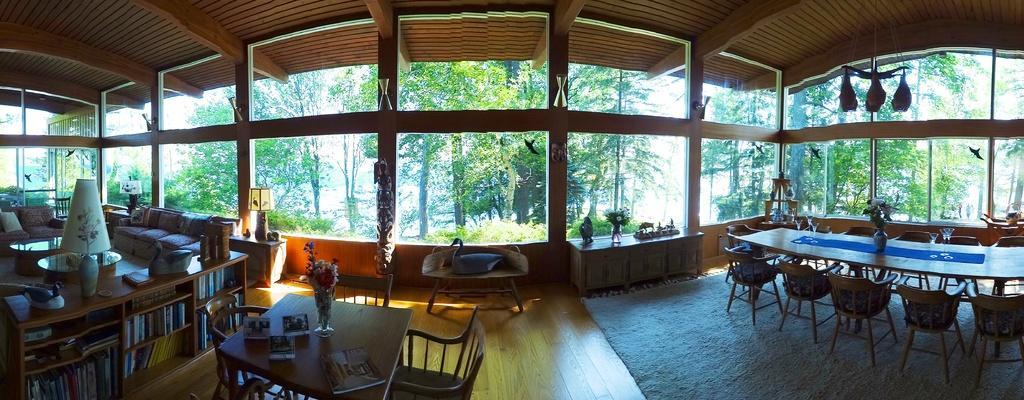How would you summarize this image in a sentence or two? This picture is taken inside the room. In this image, we can see some tables and chairs. In this image, we can also see shelf with some books, on the shelf, we can see a lamp, we can also see some other objects. In the background, we can see a window, outside the window, we can see some trees. At the bottom, we can see a mat. 